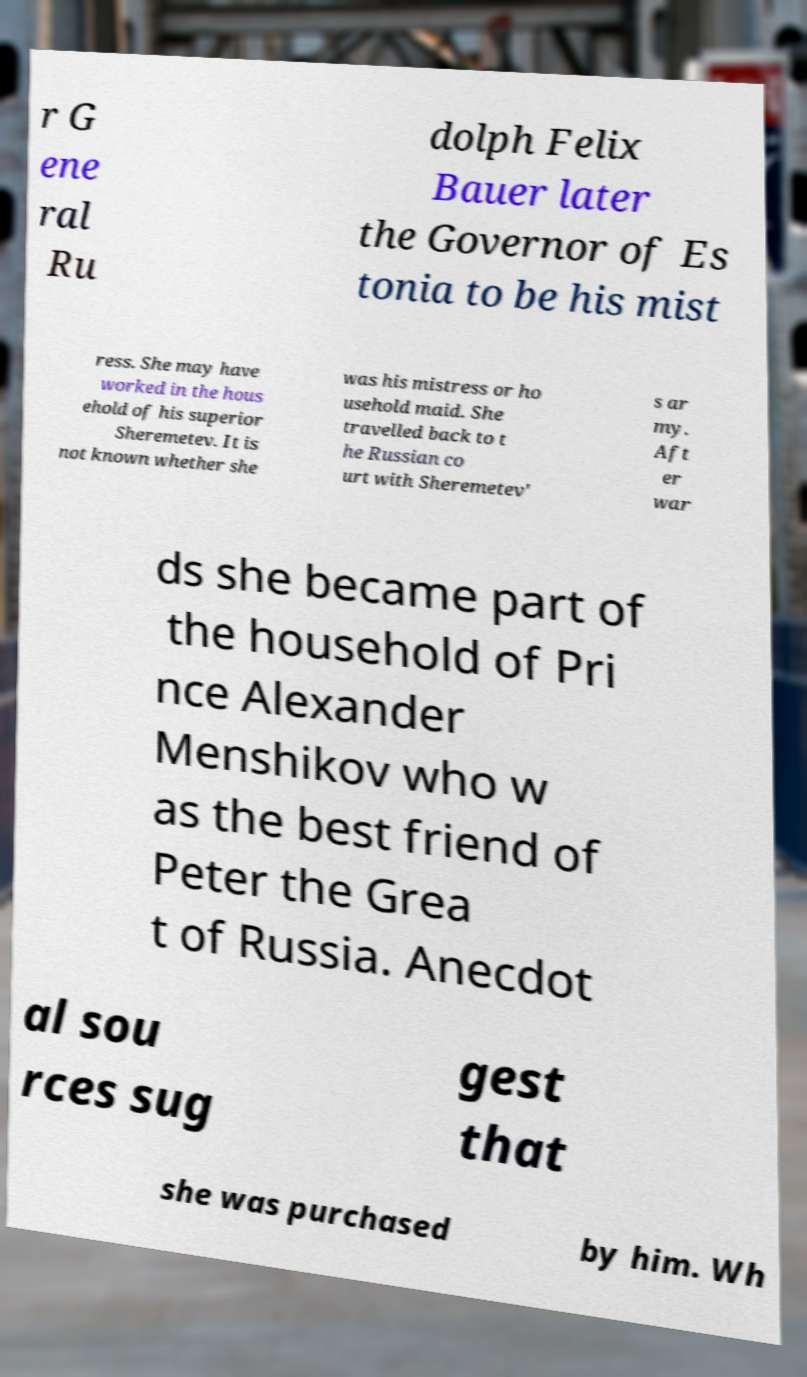What messages or text are displayed in this image? I need them in a readable, typed format. r G ene ral Ru dolph Felix Bauer later the Governor of Es tonia to be his mist ress. She may have worked in the hous ehold of his superior Sheremetev. It is not known whether she was his mistress or ho usehold maid. She travelled back to t he Russian co urt with Sheremetev' s ar my. Aft er war ds she became part of the household of Pri nce Alexander Menshikov who w as the best friend of Peter the Grea t of Russia. Anecdot al sou rces sug gest that she was purchased by him. Wh 